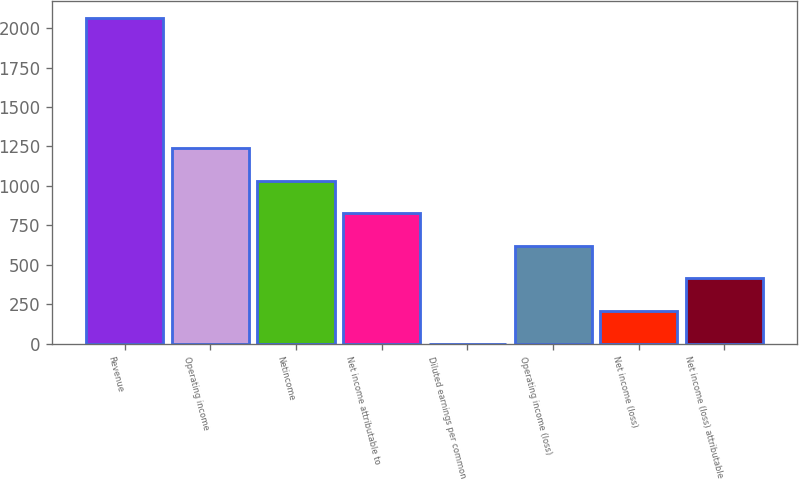<chart> <loc_0><loc_0><loc_500><loc_500><bar_chart><fcel>Revenue<fcel>Operating income<fcel>Netincome<fcel>Net income attributable to<fcel>Diluted earnings per common<fcel>Operating income (loss)<fcel>Net income (loss)<fcel>Net income (loss) attributable<nl><fcel>2066.1<fcel>1239.89<fcel>1033.34<fcel>826.79<fcel>0.59<fcel>620.24<fcel>207.14<fcel>413.69<nl></chart> 